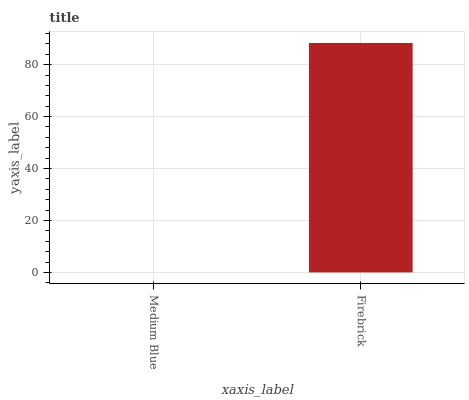Is Medium Blue the minimum?
Answer yes or no. Yes. Is Firebrick the maximum?
Answer yes or no. Yes. Is Firebrick the minimum?
Answer yes or no. No. Is Firebrick greater than Medium Blue?
Answer yes or no. Yes. Is Medium Blue less than Firebrick?
Answer yes or no. Yes. Is Medium Blue greater than Firebrick?
Answer yes or no. No. Is Firebrick less than Medium Blue?
Answer yes or no. No. Is Firebrick the high median?
Answer yes or no. Yes. Is Medium Blue the low median?
Answer yes or no. Yes. Is Medium Blue the high median?
Answer yes or no. No. Is Firebrick the low median?
Answer yes or no. No. 